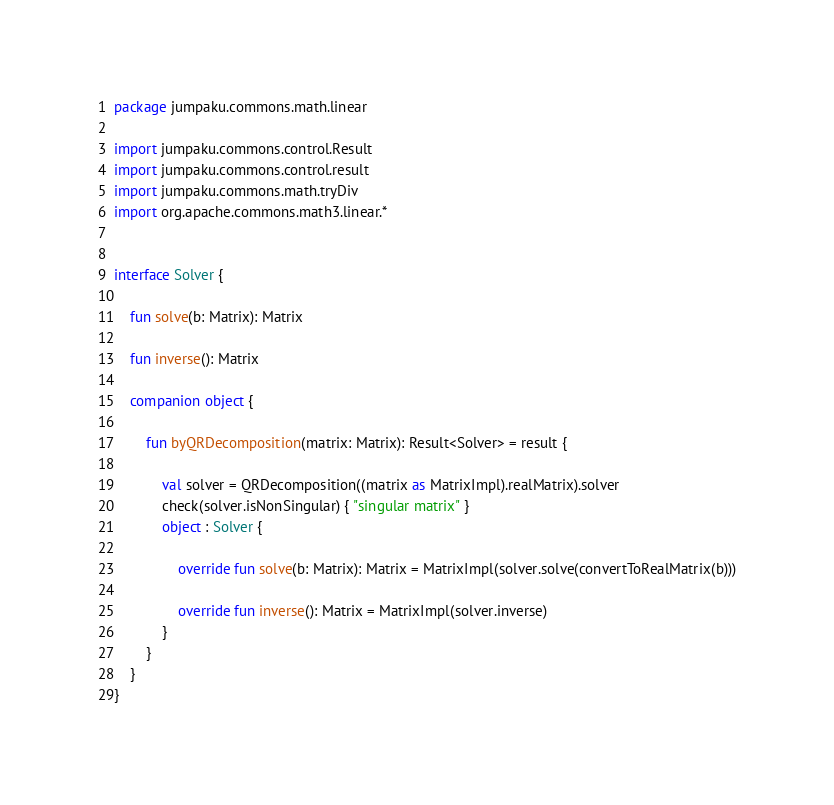Convert code to text. <code><loc_0><loc_0><loc_500><loc_500><_Kotlin_>package jumpaku.commons.math.linear

import jumpaku.commons.control.Result
import jumpaku.commons.control.result
import jumpaku.commons.math.tryDiv
import org.apache.commons.math3.linear.*


interface Solver {

    fun solve(b: Matrix): Matrix

    fun inverse(): Matrix

    companion object {

        fun byQRDecomposition(matrix: Matrix): Result<Solver> = result {

            val solver = QRDecomposition((matrix as MatrixImpl).realMatrix).solver
            check(solver.isNonSingular) { "singular matrix" }
            object : Solver {

                override fun solve(b: Matrix): Matrix = MatrixImpl(solver.solve(convertToRealMatrix(b)))

                override fun inverse(): Matrix = MatrixImpl(solver.inverse)
            }
        }
    }
}
</code> 